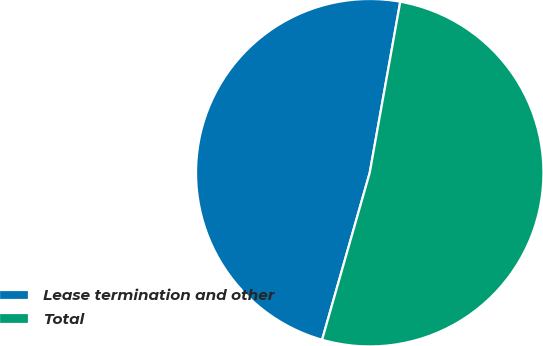Convert chart to OTSL. <chart><loc_0><loc_0><loc_500><loc_500><pie_chart><fcel>Lease termination and other<fcel>Total<nl><fcel>48.39%<fcel>51.61%<nl></chart> 